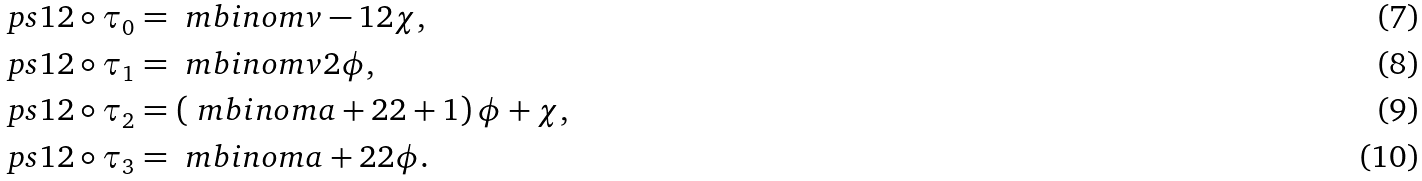<formula> <loc_0><loc_0><loc_500><loc_500>\ p s 1 2 \circ \tau _ { 0 } & = \ m b i n o m { v - 1 } 2 \chi , \\ \ p s 1 2 \circ \tau _ { 1 } & = \ m b i n o m v 2 \phi , \\ \ p s 1 2 \circ \tau _ { 2 } & = \left ( \ m b i n o m { a + 2 } 2 + 1 \right ) \phi + \chi , \\ \ p s 1 2 \circ \tau _ { 3 } & = \ m b i n o m { a + 2 } 2 \phi .</formula> 